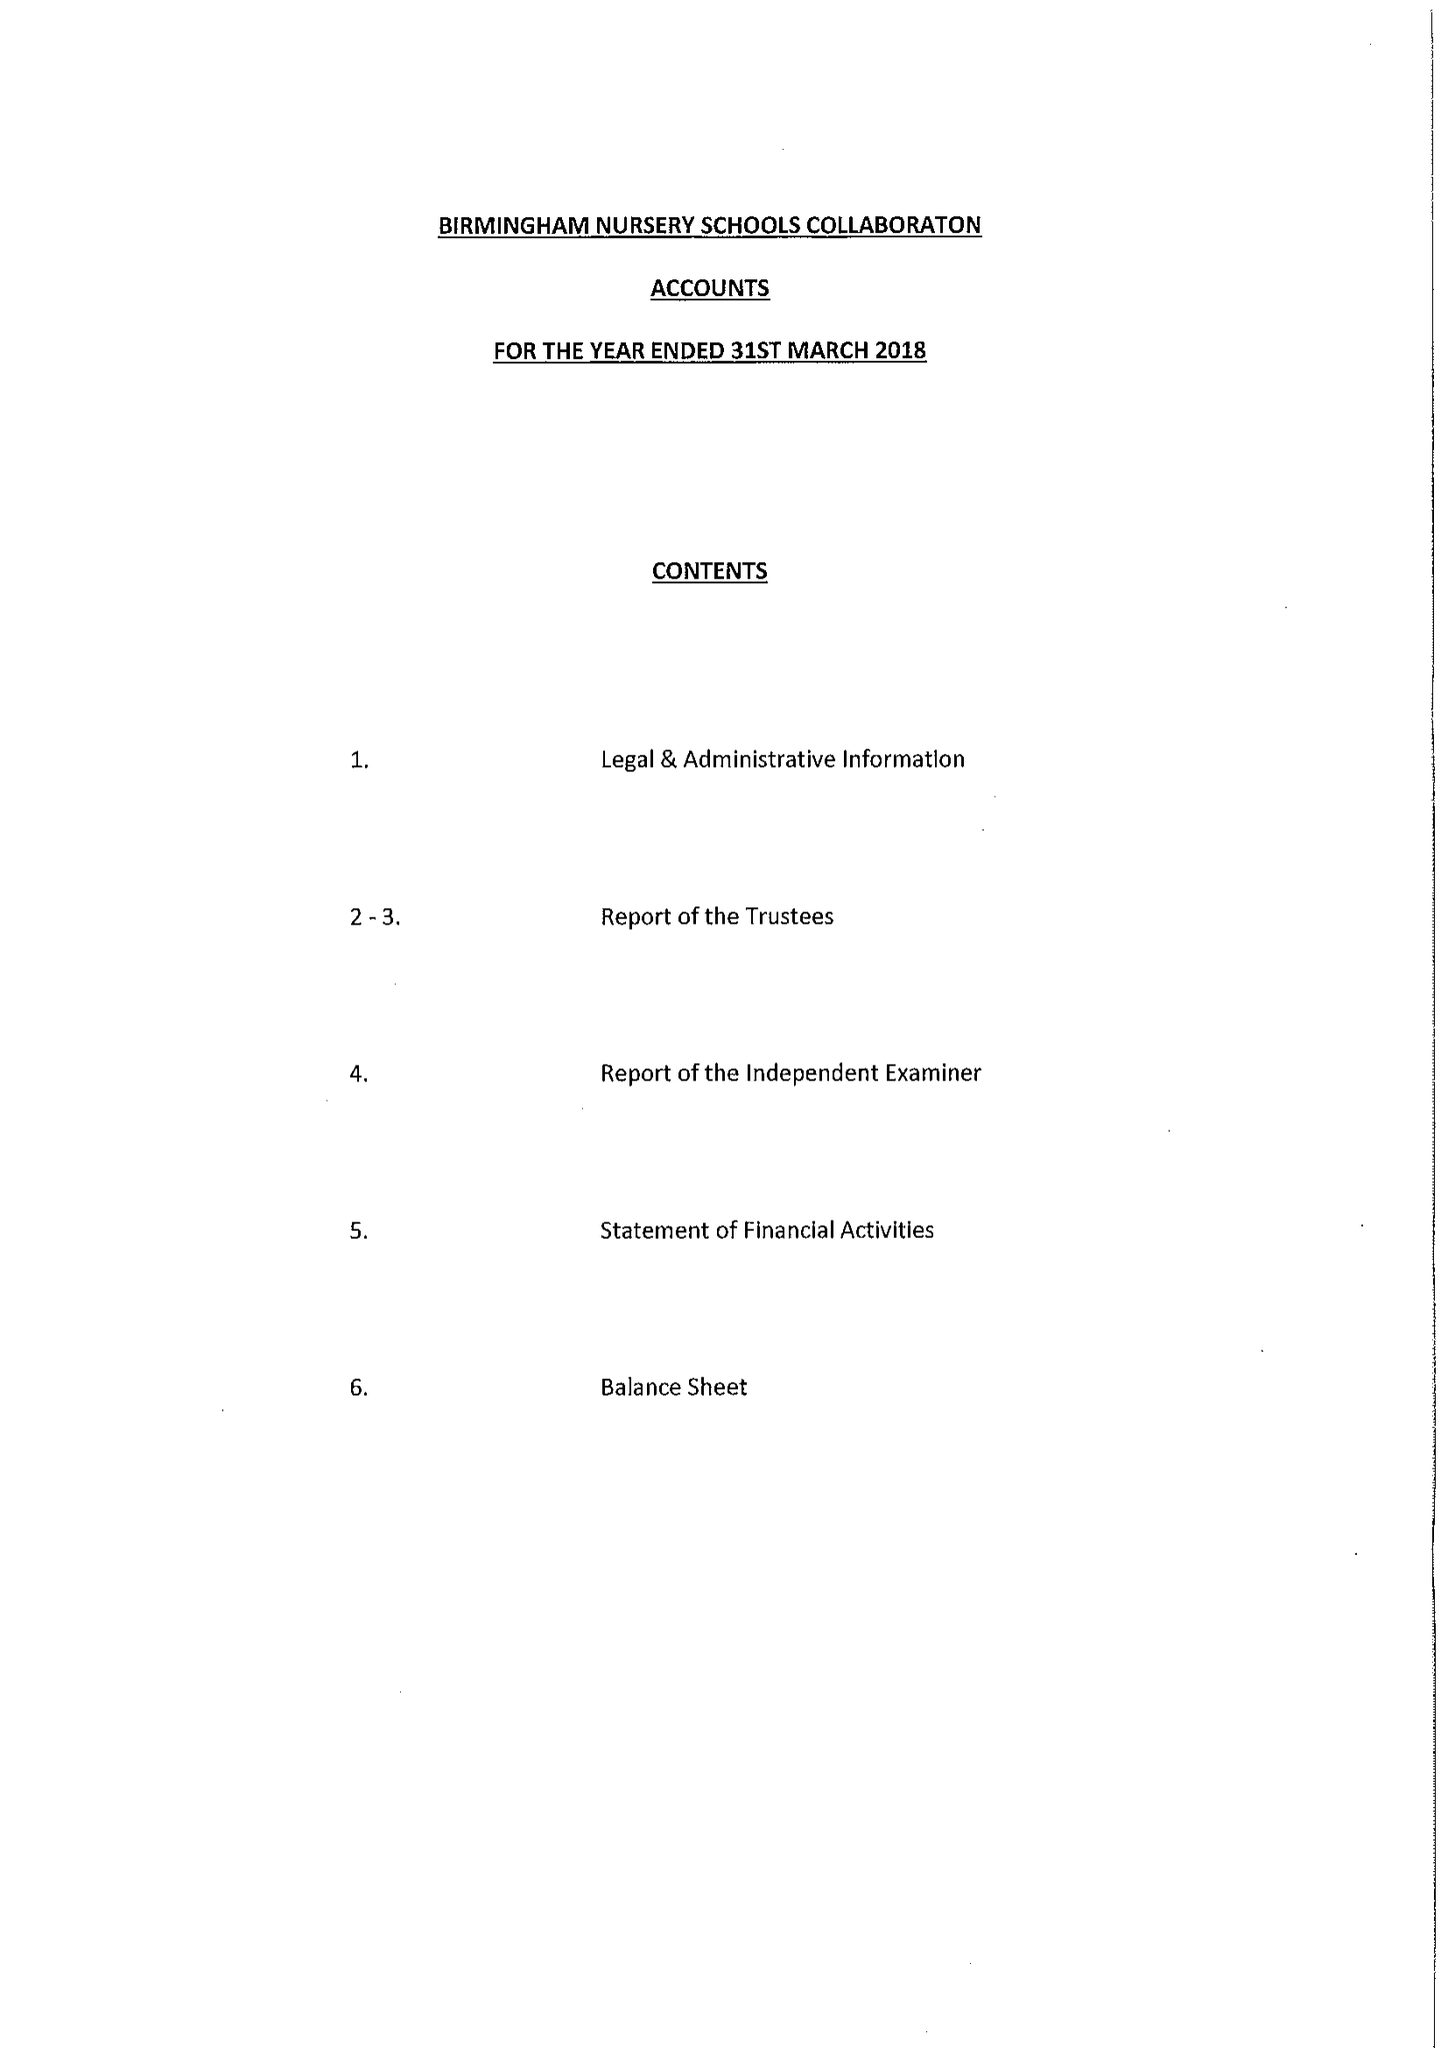What is the value for the charity_name?
Answer the question using a single word or phrase. Birmingham Nursery Schools Collaboration 